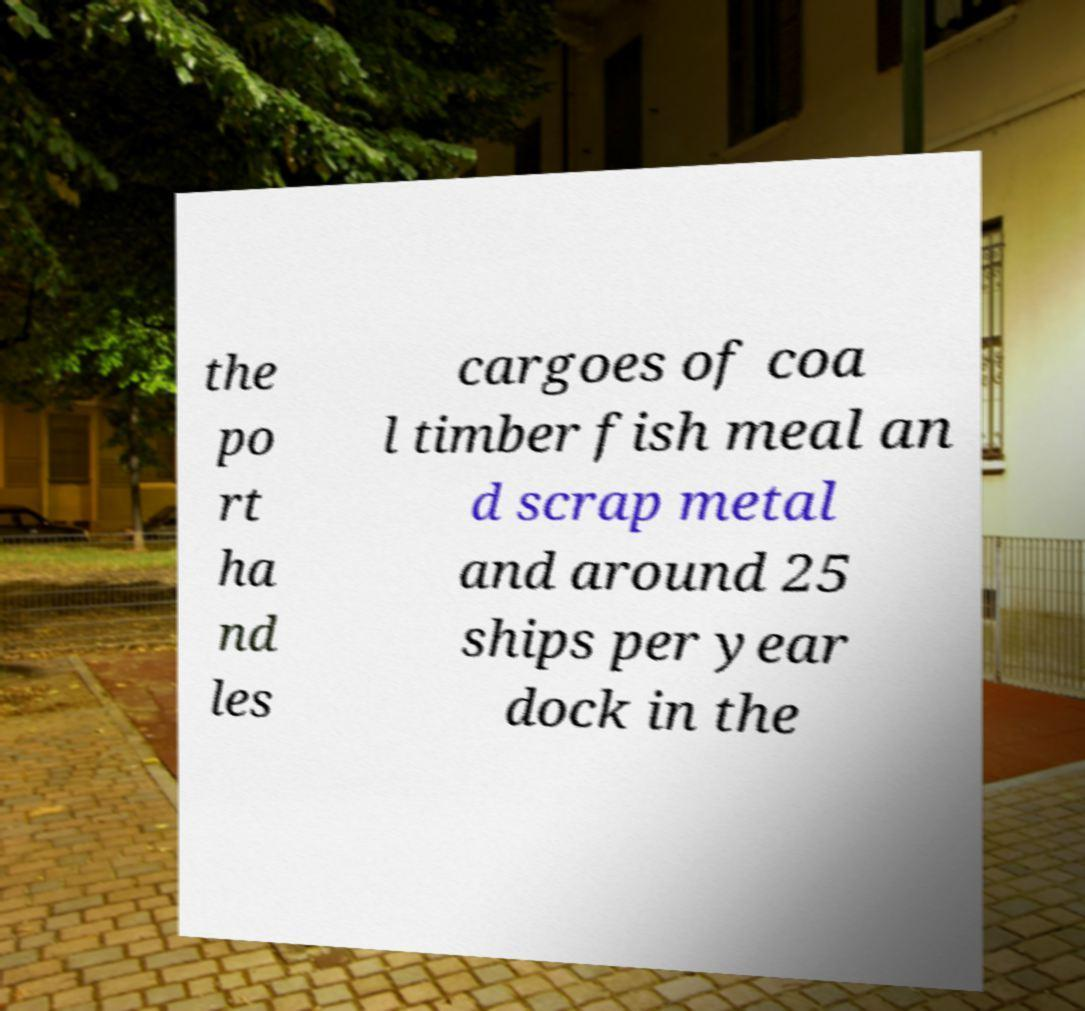Can you accurately transcribe the text from the provided image for me? the po rt ha nd les cargoes of coa l timber fish meal an d scrap metal and around 25 ships per year dock in the 